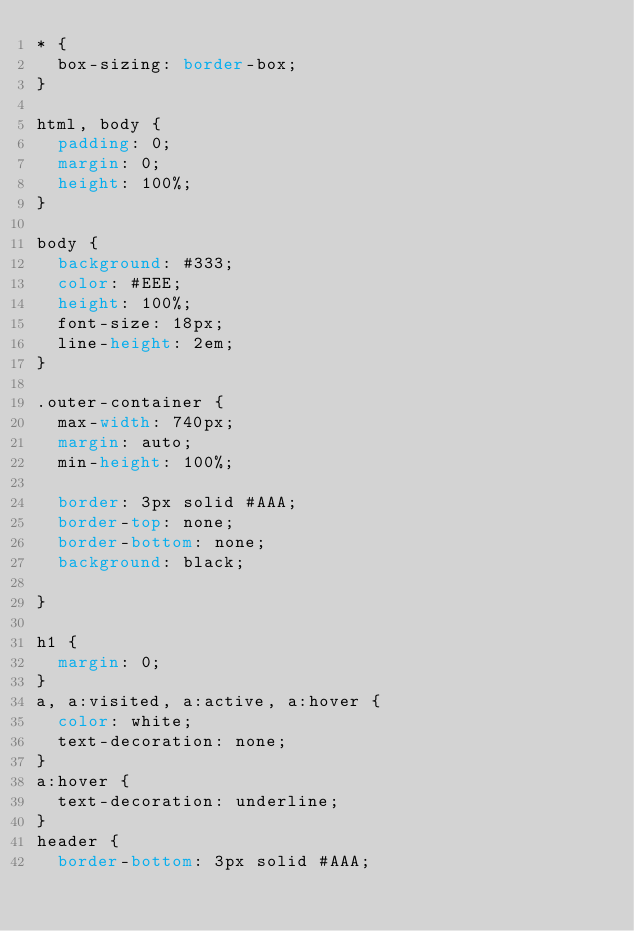Convert code to text. <code><loc_0><loc_0><loc_500><loc_500><_CSS_>* {
  box-sizing: border-box;
}

html, body {
  padding: 0;
  margin: 0;
  height: 100%;
}

body {
  background: #333;
  color: #EEE;
  height: 100%;
  font-size: 18px;
  line-height: 2em;
}

.outer-container {
  max-width: 740px;
  margin: auto;
  min-height: 100%;

  border: 3px solid #AAA;
  border-top: none;
  border-bottom: none;
  background: black;

}

h1 {
  margin: 0;
}
a, a:visited, a:active, a:hover {
  color: white;
  text-decoration: none;
}
a:hover {
  text-decoration: underline;
}
header {
  border-bottom: 3px solid #AAA;</code> 